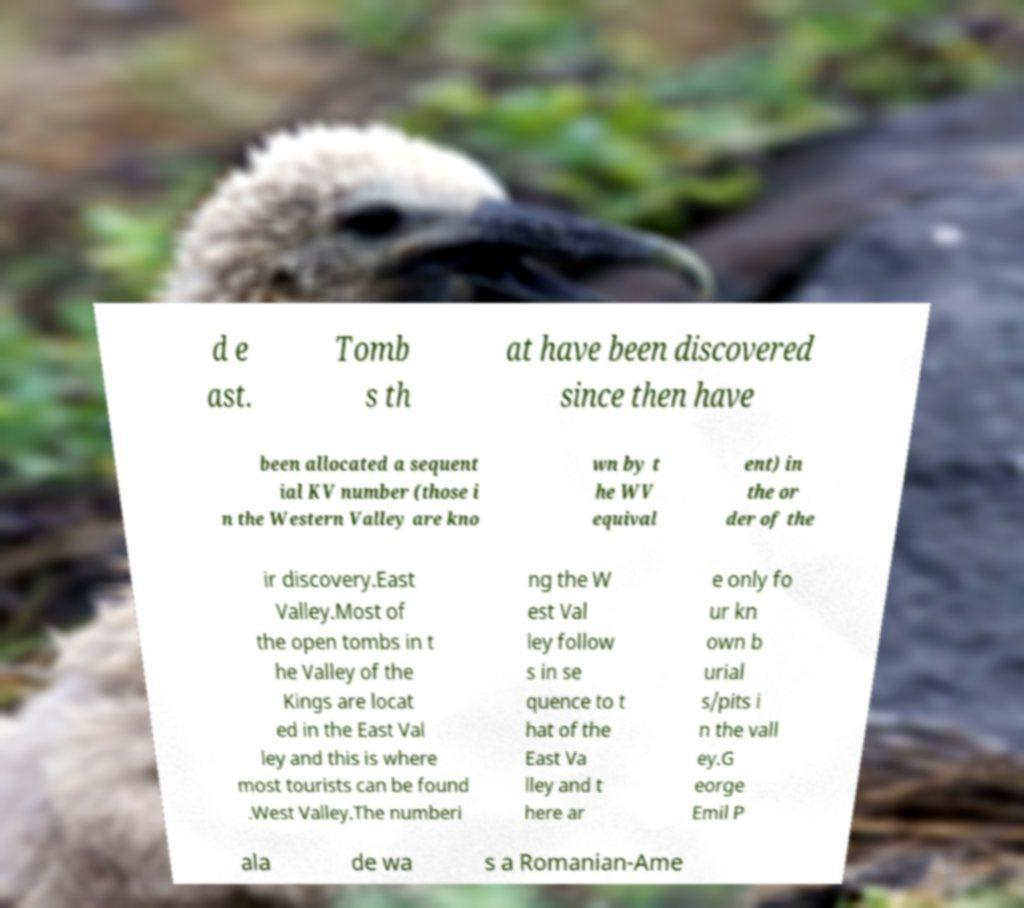Could you assist in decoding the text presented in this image and type it out clearly? d e ast. Tomb s th at have been discovered since then have been allocated a sequent ial KV number (those i n the Western Valley are kno wn by t he WV equival ent) in the or der of the ir discovery.East Valley.Most of the open tombs in t he Valley of the Kings are locat ed in the East Val ley and this is where most tourists can be found .West Valley.The numberi ng the W est Val ley follow s in se quence to t hat of the East Va lley and t here ar e only fo ur kn own b urial s/pits i n the vall ey.G eorge Emil P ala de wa s a Romanian-Ame 